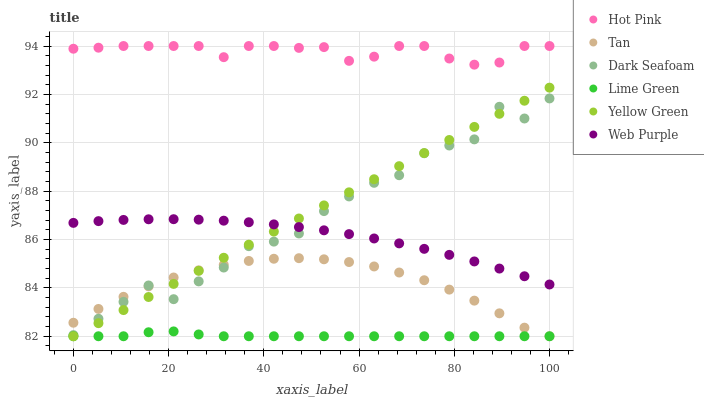Does Lime Green have the minimum area under the curve?
Answer yes or no. Yes. Does Hot Pink have the maximum area under the curve?
Answer yes or no. Yes. Does Dark Seafoam have the minimum area under the curve?
Answer yes or no. No. Does Dark Seafoam have the maximum area under the curve?
Answer yes or no. No. Is Yellow Green the smoothest?
Answer yes or no. Yes. Is Dark Seafoam the roughest?
Answer yes or no. Yes. Is Hot Pink the smoothest?
Answer yes or no. No. Is Hot Pink the roughest?
Answer yes or no. No. Does Yellow Green have the lowest value?
Answer yes or no. Yes. Does Dark Seafoam have the lowest value?
Answer yes or no. No. Does Hot Pink have the highest value?
Answer yes or no. Yes. Does Dark Seafoam have the highest value?
Answer yes or no. No. Is Dark Seafoam less than Hot Pink?
Answer yes or no. Yes. Is Hot Pink greater than Yellow Green?
Answer yes or no. Yes. Does Web Purple intersect Dark Seafoam?
Answer yes or no. Yes. Is Web Purple less than Dark Seafoam?
Answer yes or no. No. Is Web Purple greater than Dark Seafoam?
Answer yes or no. No. Does Dark Seafoam intersect Hot Pink?
Answer yes or no. No. 